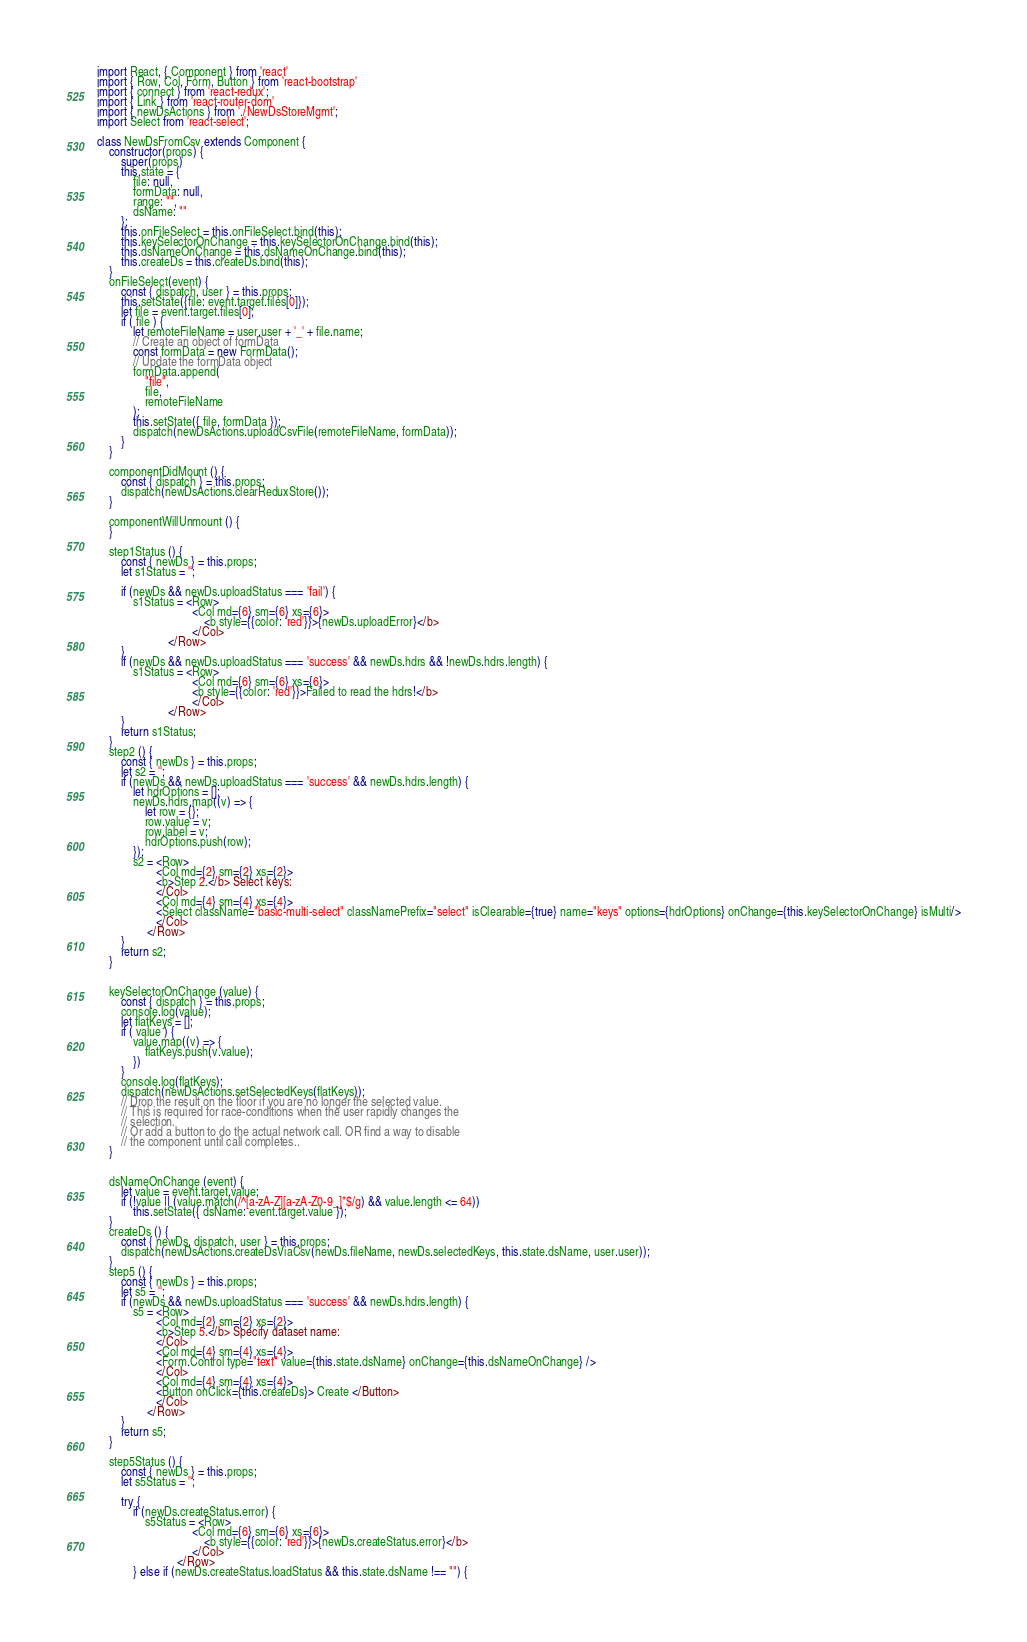<code> <loc_0><loc_0><loc_500><loc_500><_JavaScript_>import React, { Component } from 'react'
import { Row, Col, Form, Button } from 'react-bootstrap'
import { connect } from 'react-redux';
import { Link } from 'react-router-dom'
import { newDsActions } from './NewDsStoreMgmt';
import Select from 'react-select';

class NewDsFromCsv extends Component {
    constructor(props) {
        super(props)
        this.state = {
            file: null,
            formData: null,
            range: "",
            dsName: ""
        };
        this.onFileSelect = this.onFileSelect.bind(this);
        this.keySelectorOnChange = this.keySelectorOnChange.bind(this);
        this.dsNameOnChange = this.dsNameOnChange.bind(this);
        this.createDs = this.createDs.bind(this);
    }
    onFileSelect(event) {
        const { dispatch, user } = this.props;
        this.setState({file: event.target.files[0]});
        let file = event.target.files[0];
        if ( file ) {
            let remoteFileName = user.user + '_' + file.name;
            // Create an object of formData 
            const formData = new FormData(); 
            // Update the formData object 
            formData.append( 
                "file", 
                file,
                remoteFileName
            );     
            this.setState({ file, formData });
            dispatch(newDsActions.uploadCsvFile(remoteFileName, formData));
        }
    }

    componentDidMount () {
        const { dispatch } = this.props;
        dispatch(newDsActions.clearReduxStore());
    }

    componentWillUnmount () {
    }

    step1Status () {
        const { newDs } = this.props;
        let s1Status = '';

        if (newDs && newDs.uploadStatus === 'fail') {
            s1Status = <Row>
                                <Col md={6} sm={6} xs={6}> 
                                    <b style={{color: 'red'}}>{newDs.uploadError}</b>
                                </Col>
                        </Row>
        }
        if (newDs && newDs.uploadStatus === 'success' && newDs.hdrs && !newDs.hdrs.length) {
            s1Status = <Row>
                                <Col md={6} sm={6} xs={6}> 
                                <b style={{color: 'red'}}>Failed to read the hdrs!</b>
                                </Col>
                        </Row>
        }
        return s1Status;
    }
    step2 () {
        const { newDs } = this.props;
        let s2 = '';
        if (newDs && newDs.uploadStatus === 'success' && newDs.hdrs.length) {
            let hdrOptions = [];
            newDs.hdrs.map((v) => {
                let row = {};
                row.value = v;
                row.label = v;
                hdrOptions.push(row);
            });
            s2 = <Row>
                    <Col md={2} sm={2} xs={2}> 
                    <b>Step 2.</b> Select keys:
                    </Col>
                    <Col md={4} sm={4} xs={4}> 
                    <Select className="basic-multi-select" classNamePrefix="select" isClearable={true} name="keys" options={hdrOptions} onChange={this.keySelectorOnChange} isMulti/>
                    </Col>
                 </Row>
        }
        return s2;
    }


    keySelectorOnChange (value) {
        const { dispatch } = this.props;
        console.log(value);
        let flatKeys = [];
        if ( value ) {
            value.map((v) => {
                flatKeys.push(v.value);
            })
        }
        console.log(flatKeys);
        dispatch(newDsActions.setSelectedKeys(flatKeys));
        // Drop the result on the floor if you are no longer the selected value. 
        // This is required for race-conditions when the user rapidly changes the
        // selection. 
        // Or add a button to do the actual network call. OR find a way to disable
        // the component until call completes..
    }


    dsNameOnChange (event) {
        let value = event.target.value;
        if (!value || (value.match(/^[a-zA-Z][a-zA-Z0-9_]*$/g) && value.length <= 64))
            this.setState({ dsName: event.target.value });
    }
    createDs () {
        const { newDs, dispatch, user } = this.props;
        dispatch(newDsActions.createDsViaCsv(newDs.fileName, newDs.selectedKeys, this.state.dsName, user.user));
    }
    step5 () {
        const { newDs } = this.props;
        let s5 = '';
        if (newDs && newDs.uploadStatus === 'success' && newDs.hdrs.length) {
            s5 = <Row>
                    <Col md={2} sm={2} xs={2}> 
                    <b>Step 5.</b> Specify dataset name:
                    </Col>
                    <Col md={4} sm={4} xs={4}> 
                    <Form.Control type="text" value={this.state.dsName} onChange={this.dsNameOnChange} />
                    </Col>
                    <Col md={4} sm={4} xs={4}> 
                    <Button onClick={this.createDs}> Create </Button> 
                    </Col>
                 </Row>
        }
        return s5;
    }

    step5Status () {
        const { newDs } = this.props;
        let s5Status = '';

        try {
            if (newDs.createStatus.error) {
                s5Status = <Row>
                                <Col md={6} sm={6} xs={6}> 
                                    <b style={{color: 'red'}}>{newDs.createStatus.error}</b>
                                </Col>
                           </Row>
            } else if (newDs.createStatus.loadStatus && this.state.dsName !== "") {</code> 